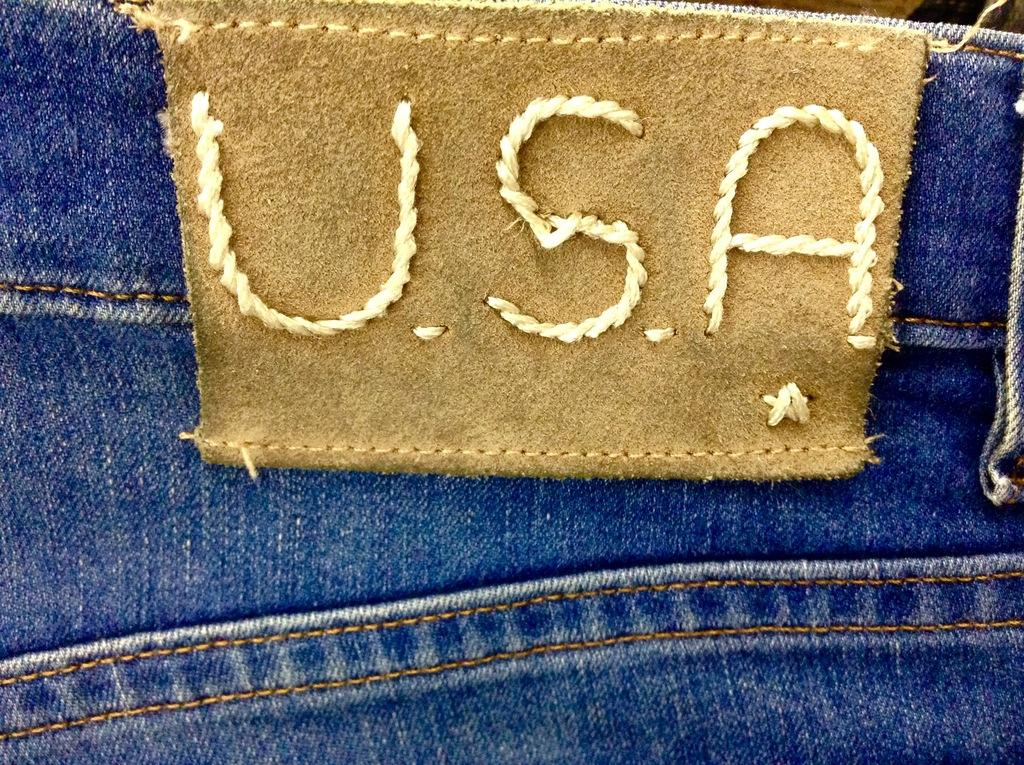What type of clothing item is in the image? There is a pair of jeans in the image. What color are the jeans? The jeans are blue in color. Is there any additional information about the jeans? Yes, there is a label on the jeans. What street is the jeans taking a voyage on in the image? The jeans are not taking a voyage, nor is there a street present in the image. 